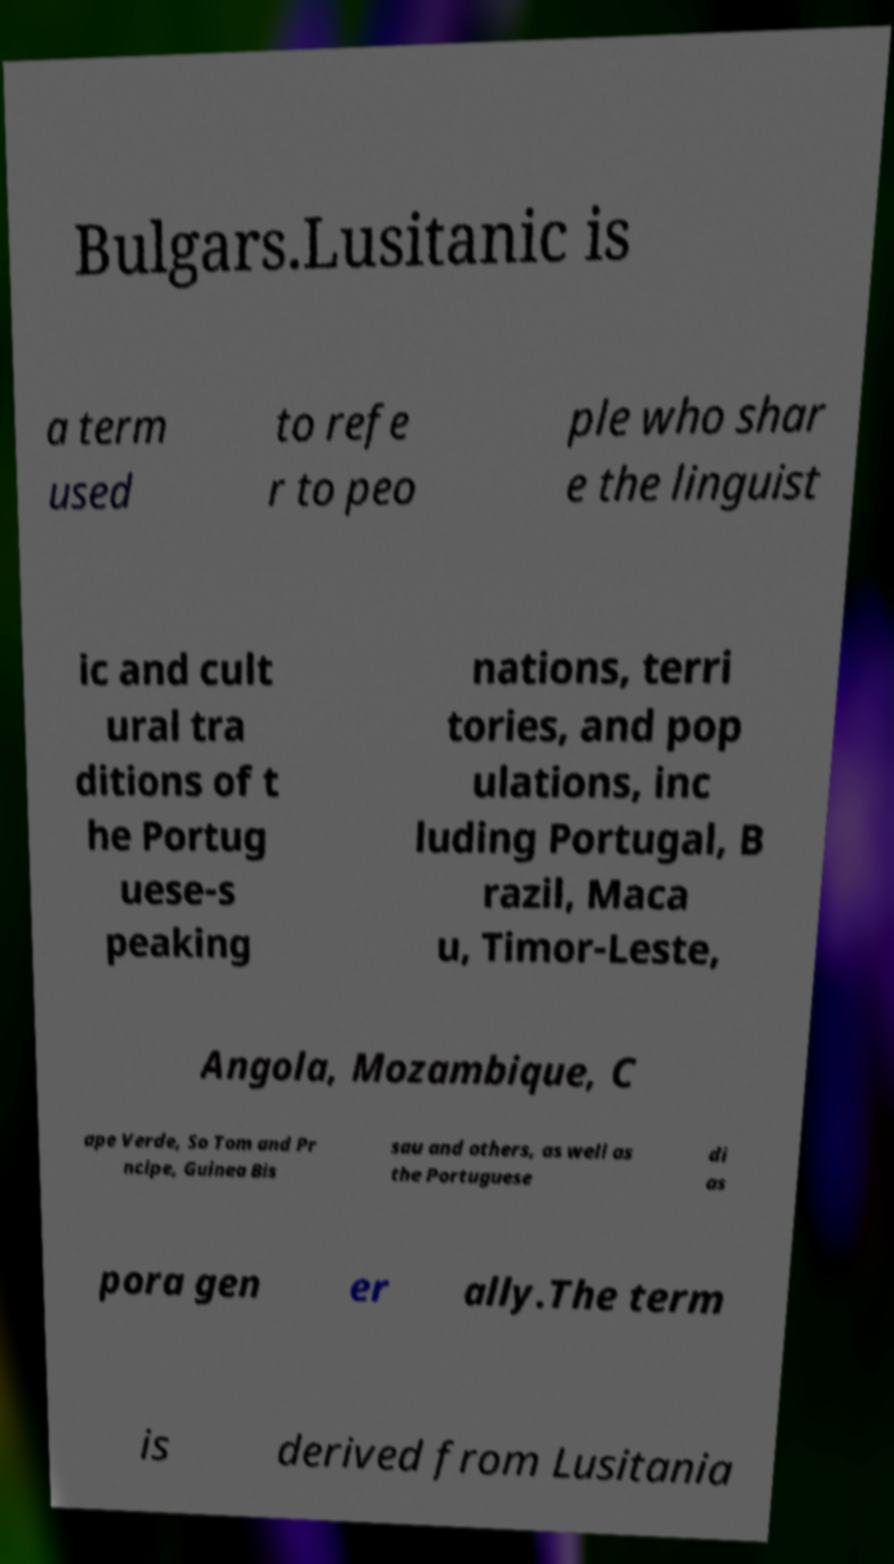I need the written content from this picture converted into text. Can you do that? Bulgars.Lusitanic is a term used to refe r to peo ple who shar e the linguist ic and cult ural tra ditions of t he Portug uese-s peaking nations, terri tories, and pop ulations, inc luding Portugal, B razil, Maca u, Timor-Leste, Angola, Mozambique, C ape Verde, So Tom and Pr ncipe, Guinea Bis sau and others, as well as the Portuguese di as pora gen er ally.The term is derived from Lusitania 